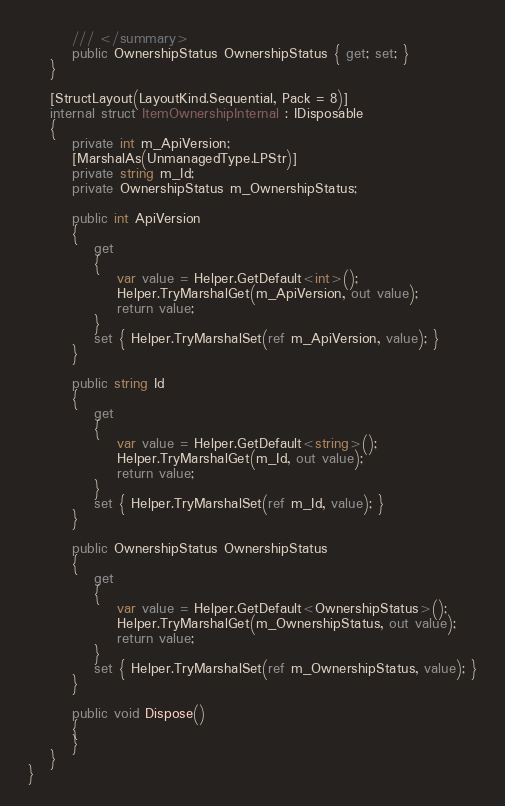<code> <loc_0><loc_0><loc_500><loc_500><_C#_>		/// </summary>
		public OwnershipStatus OwnershipStatus { get; set; }
	}

	[StructLayout(LayoutKind.Sequential, Pack = 8)]
	internal struct ItemOwnershipInternal : IDisposable
	{
		private int m_ApiVersion;
		[MarshalAs(UnmanagedType.LPStr)]
		private string m_Id;
		private OwnershipStatus m_OwnershipStatus;

		public int ApiVersion
		{
			get
			{
				var value = Helper.GetDefault<int>();
				Helper.TryMarshalGet(m_ApiVersion, out value);
				return value;
			}
			set { Helper.TryMarshalSet(ref m_ApiVersion, value); }
		}

		public string Id
		{
			get
			{
				var value = Helper.GetDefault<string>();
				Helper.TryMarshalGet(m_Id, out value);
				return value;
			}
			set { Helper.TryMarshalSet(ref m_Id, value); }
		}

		public OwnershipStatus OwnershipStatus
		{
			get
			{
				var value = Helper.GetDefault<OwnershipStatus>();
				Helper.TryMarshalGet(m_OwnershipStatus, out value);
				return value;
			}
			set { Helper.TryMarshalSet(ref m_OwnershipStatus, value); }
		}

		public void Dispose()
		{
		}
	}
}</code> 